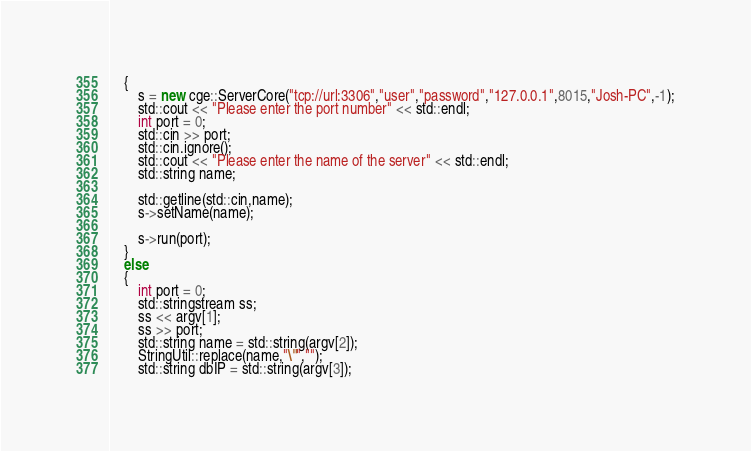Convert code to text. <code><loc_0><loc_0><loc_500><loc_500><_C++_>	{
		s = new cge::ServerCore("tcp://url:3306","user","password","127.0.0.1",8015,"Josh-PC",-1);
		std::cout << "Please enter the port number" << std::endl;
		int port = 0;
		std::cin >> port;
		std::cin.ignore();
		std::cout << "Please enter the name of the server" << std::endl;
		std::string name;

		std::getline(std::cin,name);
		s->setName(name);

		s->run(port);
	}
	else
	{
		int port = 0;
		std::stringstream ss;
		ss << argv[1];
		ss >> port;
		std::string name = std::string(argv[2]);
		StringUtil::replace(name,"\"","");
		std::string dbIP = std::string(argv[3]);</code> 